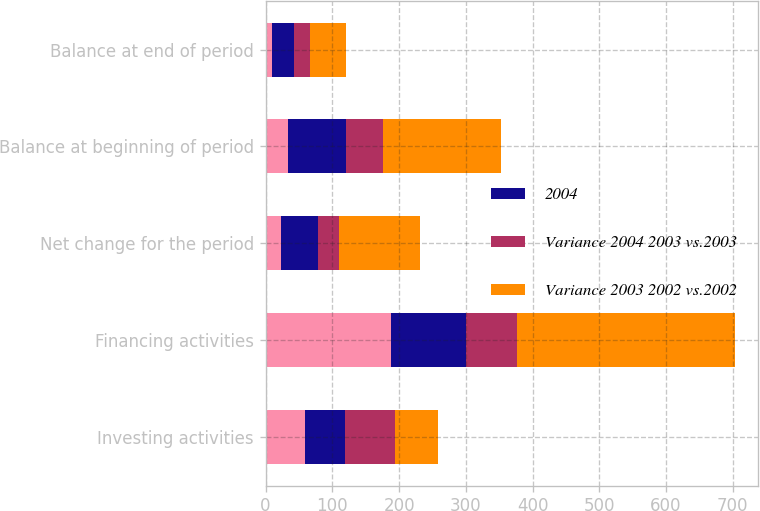Convert chart to OTSL. <chart><loc_0><loc_0><loc_500><loc_500><stacked_bar_chart><ecel><fcel>Investing activities<fcel>Financing activities<fcel>Net change for the period<fcel>Balance at beginning of period<fcel>Balance at end of period<nl><fcel>nan<fcel>59.5<fcel>188<fcel>23<fcel>33<fcel>10<nl><fcel>2004<fcel>59.5<fcel>113<fcel>55<fcel>88<fcel>33<nl><fcel>Variance 2004 2003 vs.2003<fcel>75<fcel>75<fcel>32<fcel>55<fcel>23<nl><fcel>Variance 2003 2002 vs.2002<fcel>64<fcel>327<fcel>122<fcel>177<fcel>55<nl></chart> 